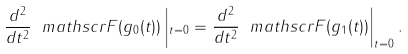<formula> <loc_0><loc_0><loc_500><loc_500>\frac { d ^ { 2 } } { d t ^ { 2 } } \ m a t h s c r { F } ( g _ { 0 } ( t ) ) \left | _ { t = 0 } = \frac { d ^ { 2 } } { d t ^ { 2 } } \ m a t h s c r { F } ( g _ { 1 } ( t ) ) \right | _ { t = 0 } .</formula> 